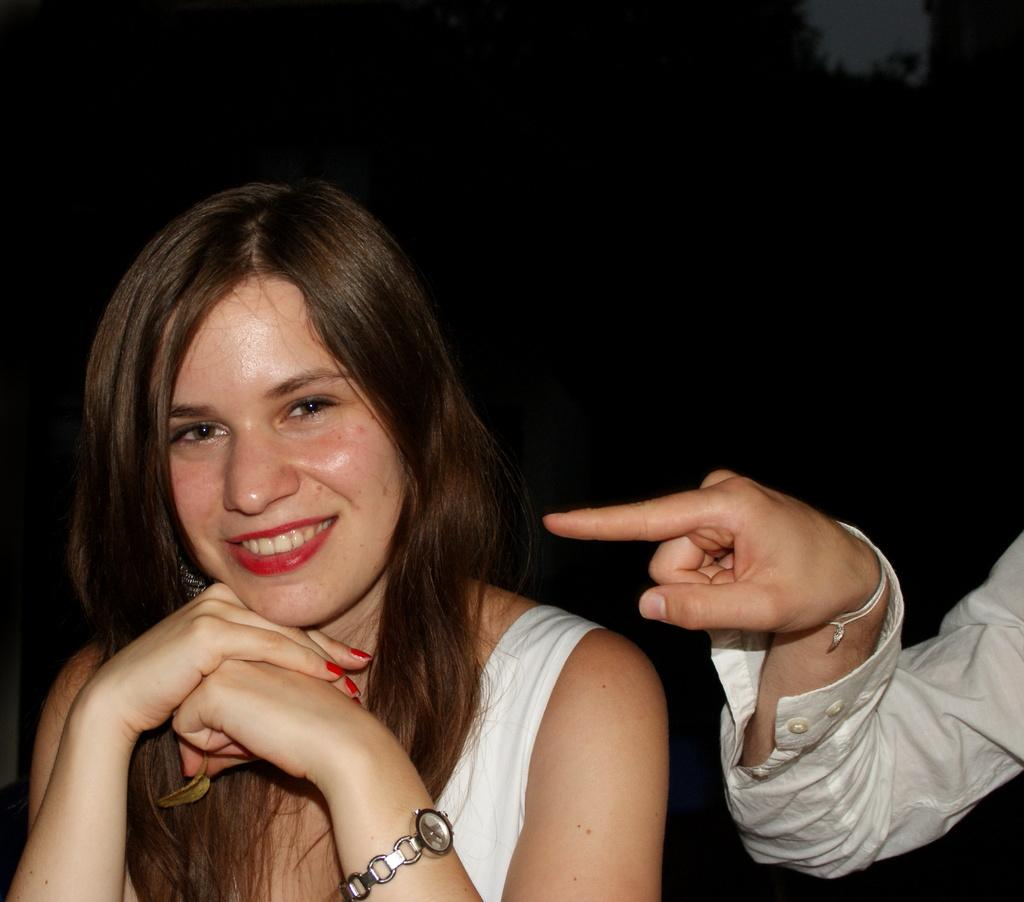What is the main subject of the image? There is a person in the image. Can you describe a specific part of the person's body that is visible? The hand of a person is visible on the right side of the image. What can be observed about the overall setting of the image? The background of the image is dark. How does the person increase the size of the paper in the image? There is no paper present in the image, so the person cannot increase its size. 